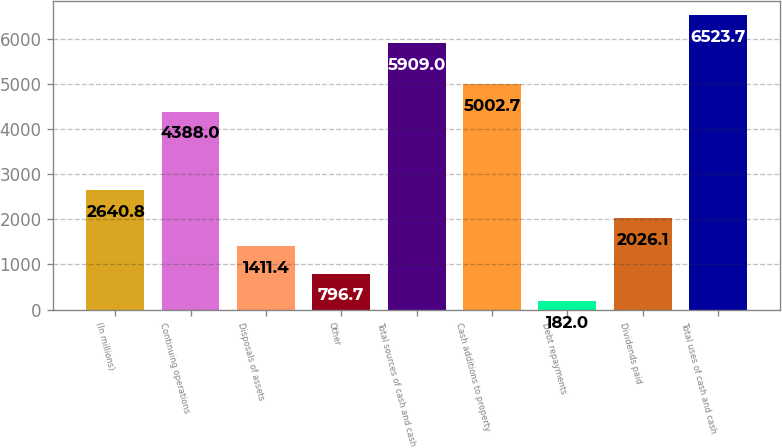Convert chart to OTSL. <chart><loc_0><loc_0><loc_500><loc_500><bar_chart><fcel>(In millions)<fcel>Continuing operations<fcel>Disposals of assets<fcel>Other<fcel>Total sources of cash and cash<fcel>Cash additions to property<fcel>Debt repayments<fcel>Dividends paid<fcel>Total uses of cash and cash<nl><fcel>2640.8<fcel>4388<fcel>1411.4<fcel>796.7<fcel>5909<fcel>5002.7<fcel>182<fcel>2026.1<fcel>6523.7<nl></chart> 